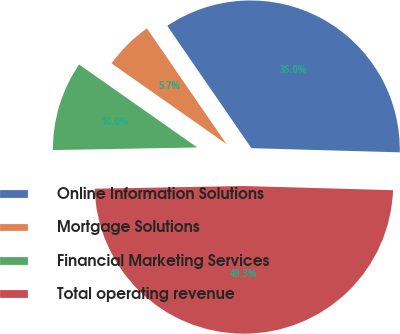Convert chart. <chart><loc_0><loc_0><loc_500><loc_500><pie_chart><fcel>Online Information Solutions<fcel>Mortgage Solutions<fcel>Financial Marketing Services<fcel>Total operating revenue<nl><fcel>35.04%<fcel>5.67%<fcel>10.03%<fcel>49.27%<nl></chart> 